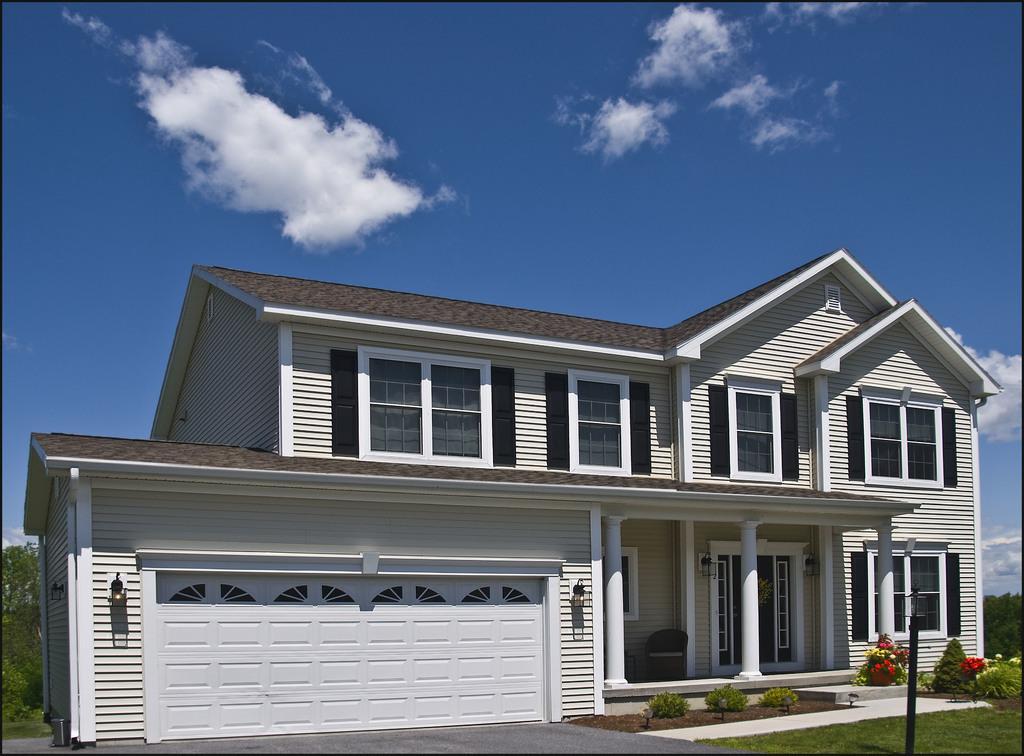In one or two sentences, can you explain what this image depicts? In this image I can see building,trees,pole and glass windows. Building is in white and brown color. The sky is in white and blue color. 